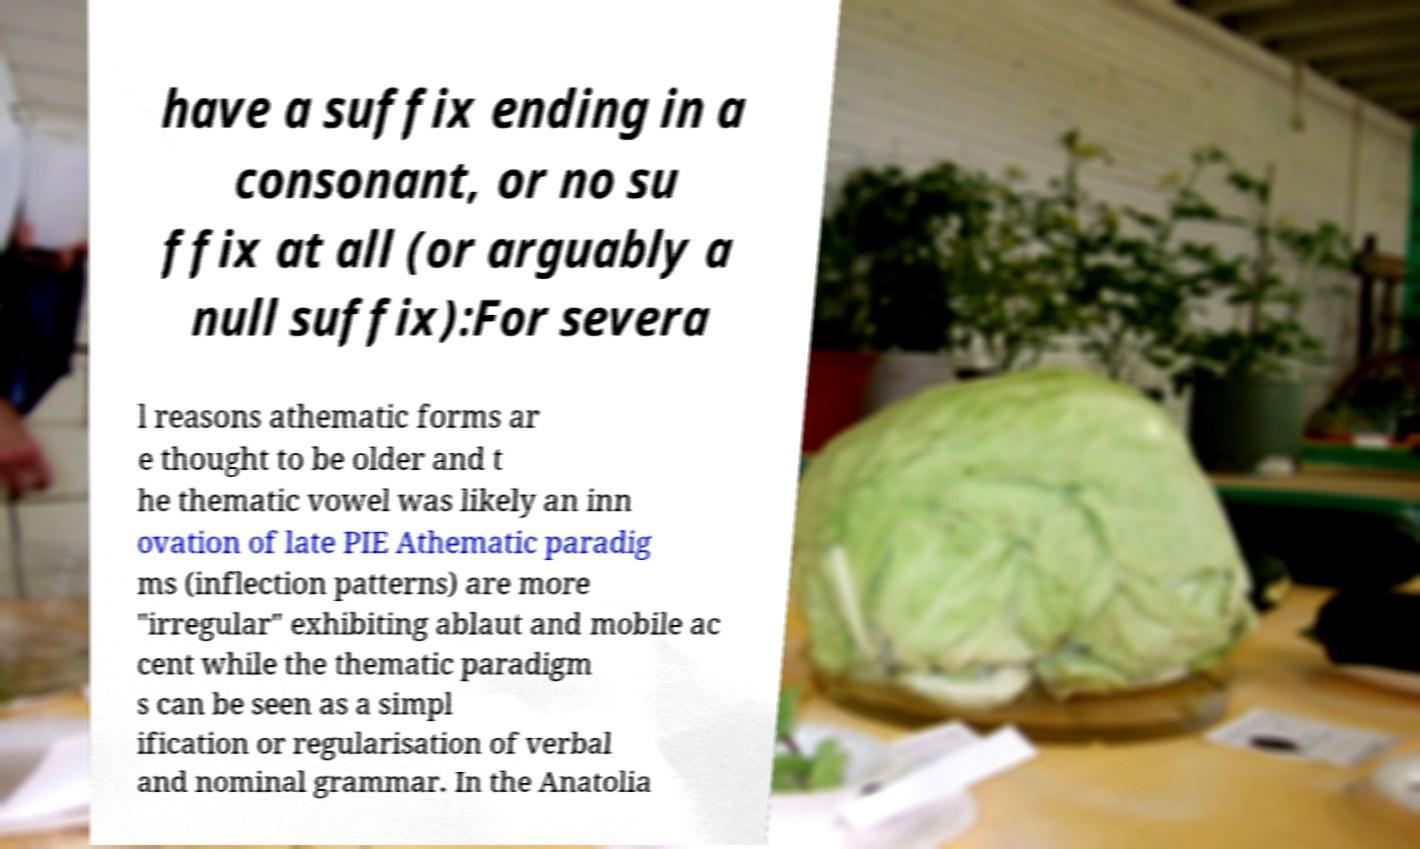There's text embedded in this image that I need extracted. Can you transcribe it verbatim? have a suffix ending in a consonant, or no su ffix at all (or arguably a null suffix):For severa l reasons athematic forms ar e thought to be older and t he thematic vowel was likely an inn ovation of late PIE Athematic paradig ms (inflection patterns) are more "irregular" exhibiting ablaut and mobile ac cent while the thematic paradigm s can be seen as a simpl ification or regularisation of verbal and nominal grammar. In the Anatolia 